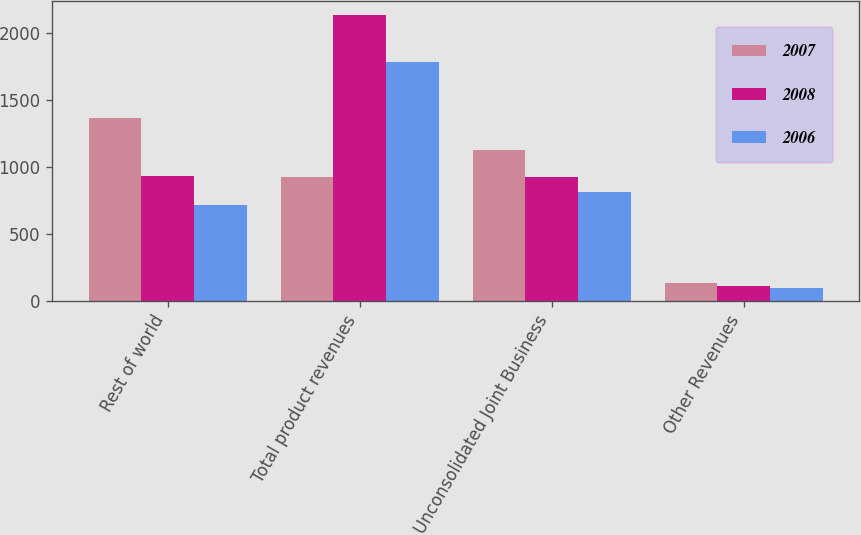<chart> <loc_0><loc_0><loc_500><loc_500><stacked_bar_chart><ecel><fcel>Rest of world<fcel>Total product revenues<fcel>Unconsolidated Joint Business<fcel>Other Revenues<nl><fcel>2007<fcel>1366.8<fcel>926.1<fcel>1128.2<fcel>129.6<nl><fcel>2008<fcel>933.2<fcel>2136.8<fcel>926.1<fcel>108.7<nl><fcel>2006<fcel>711.8<fcel>1781.3<fcel>810.9<fcel>90.8<nl></chart> 